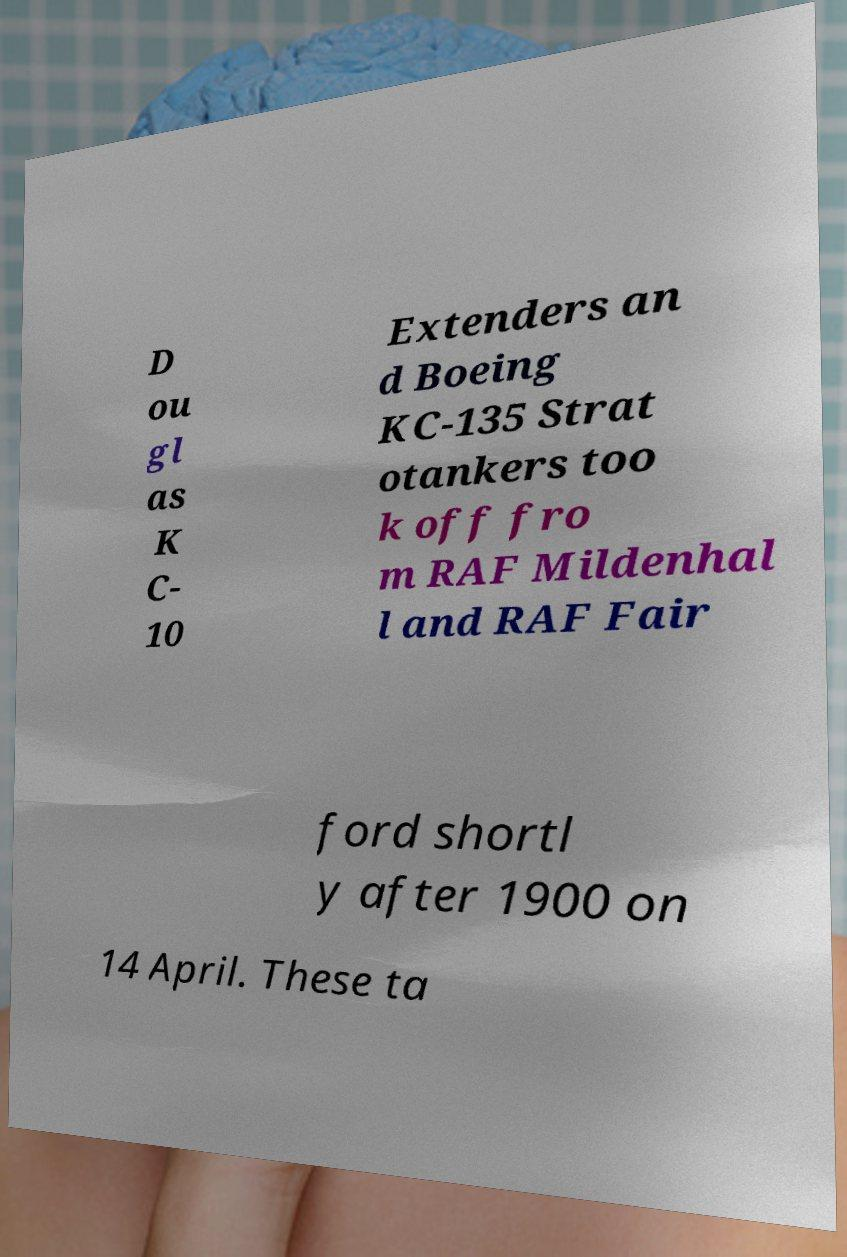I need the written content from this picture converted into text. Can you do that? D ou gl as K C- 10 Extenders an d Boeing KC-135 Strat otankers too k off fro m RAF Mildenhal l and RAF Fair ford shortl y after 1900 on 14 April. These ta 